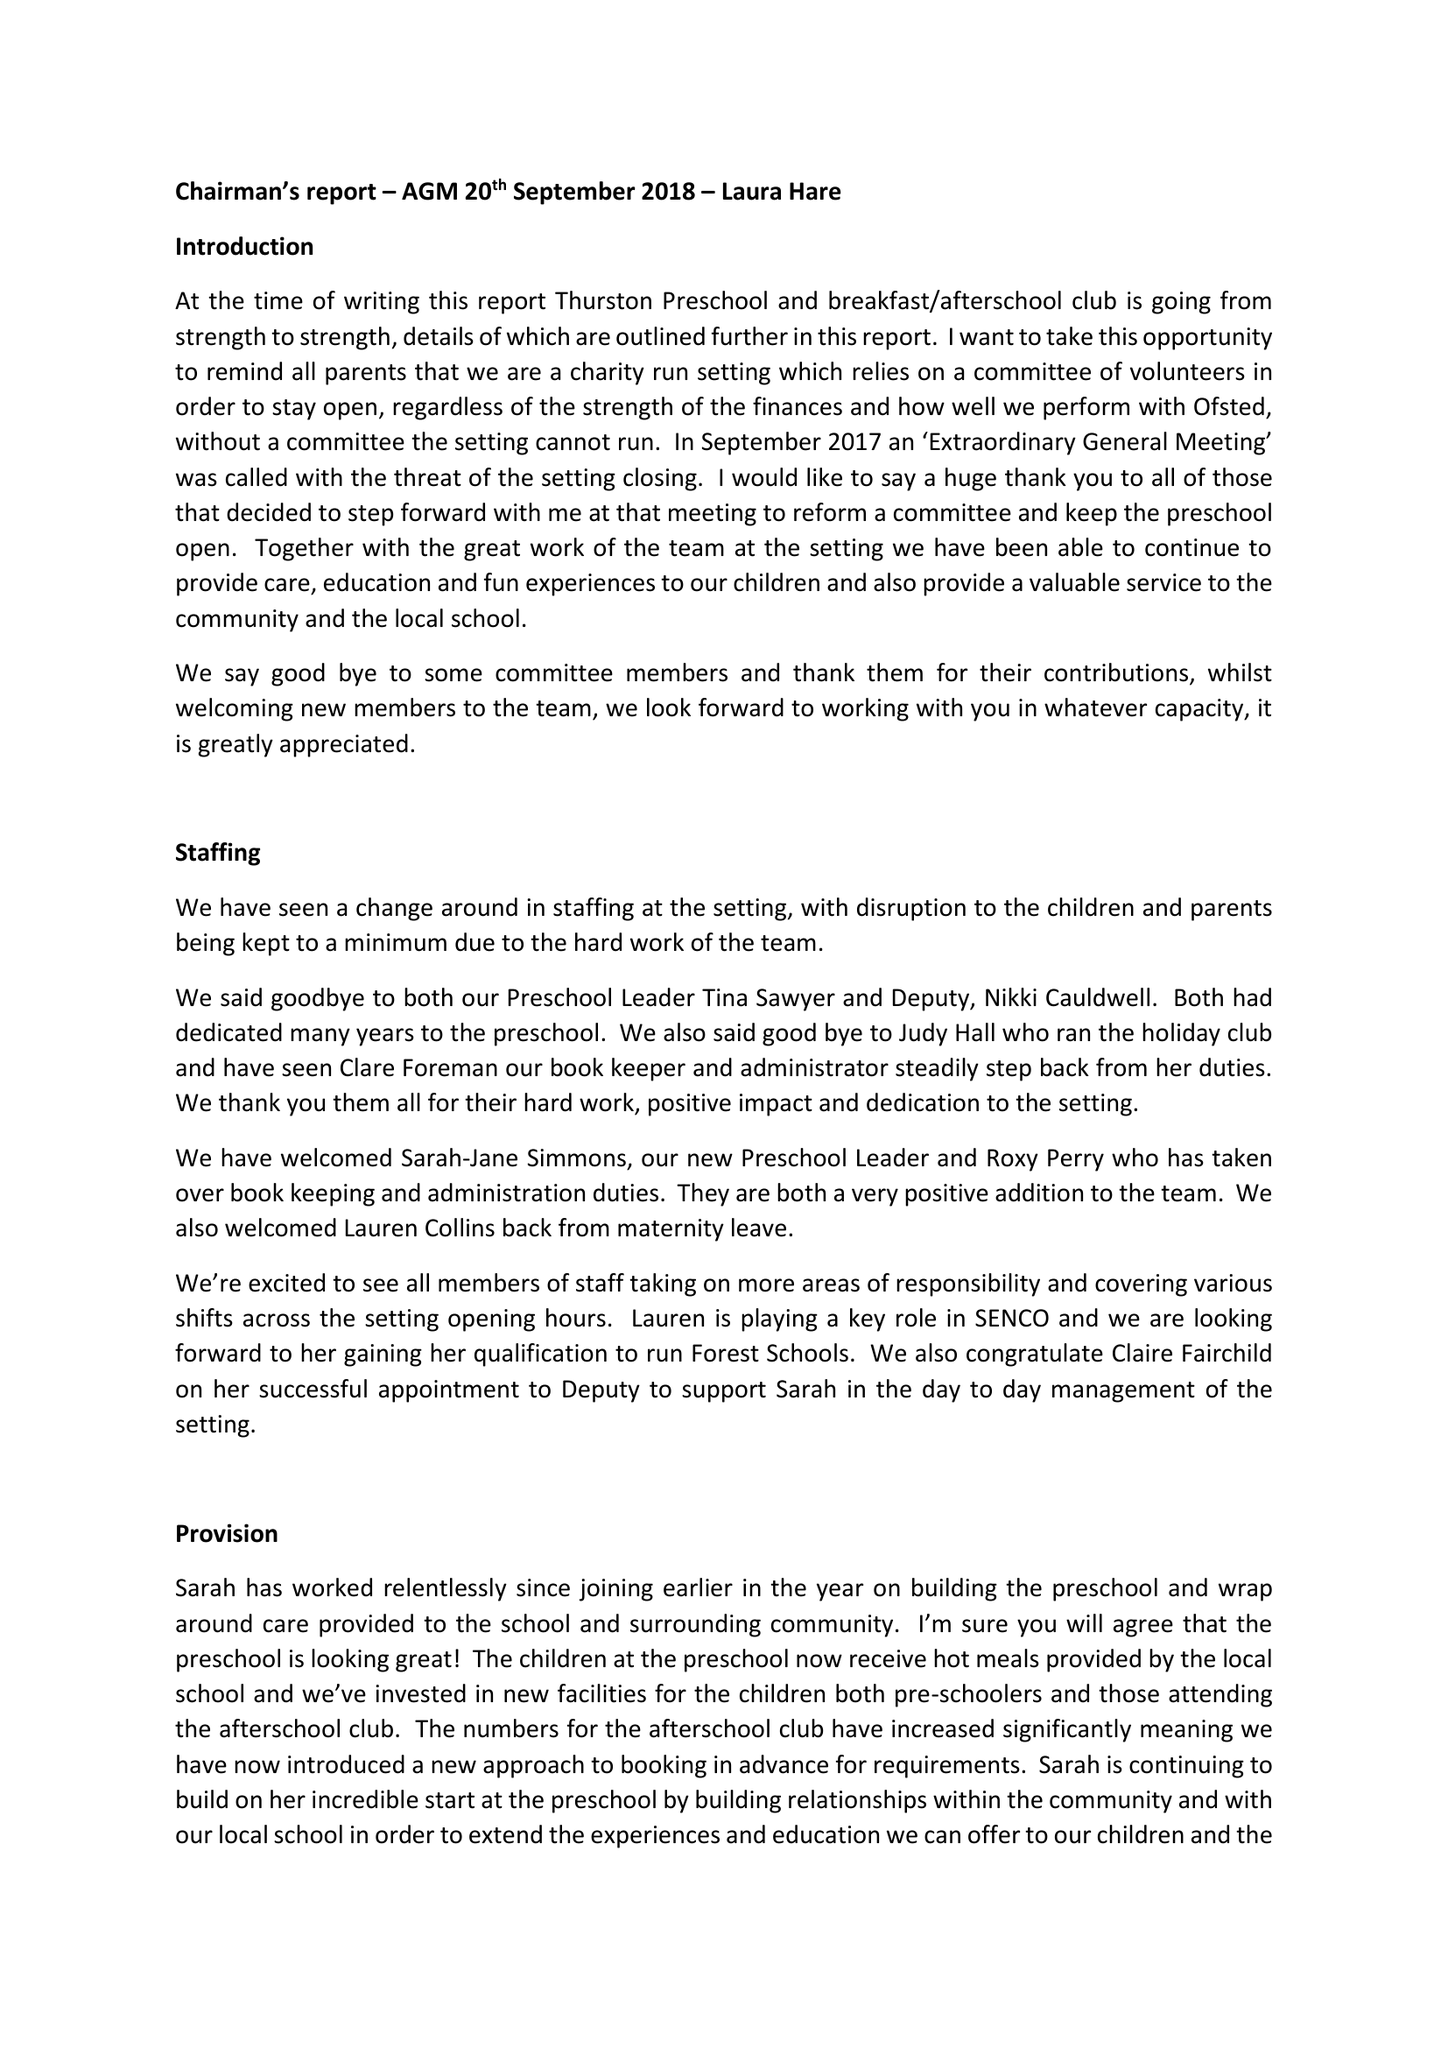What is the value for the report_date?
Answer the question using a single word or phrase. 2018-08-31 